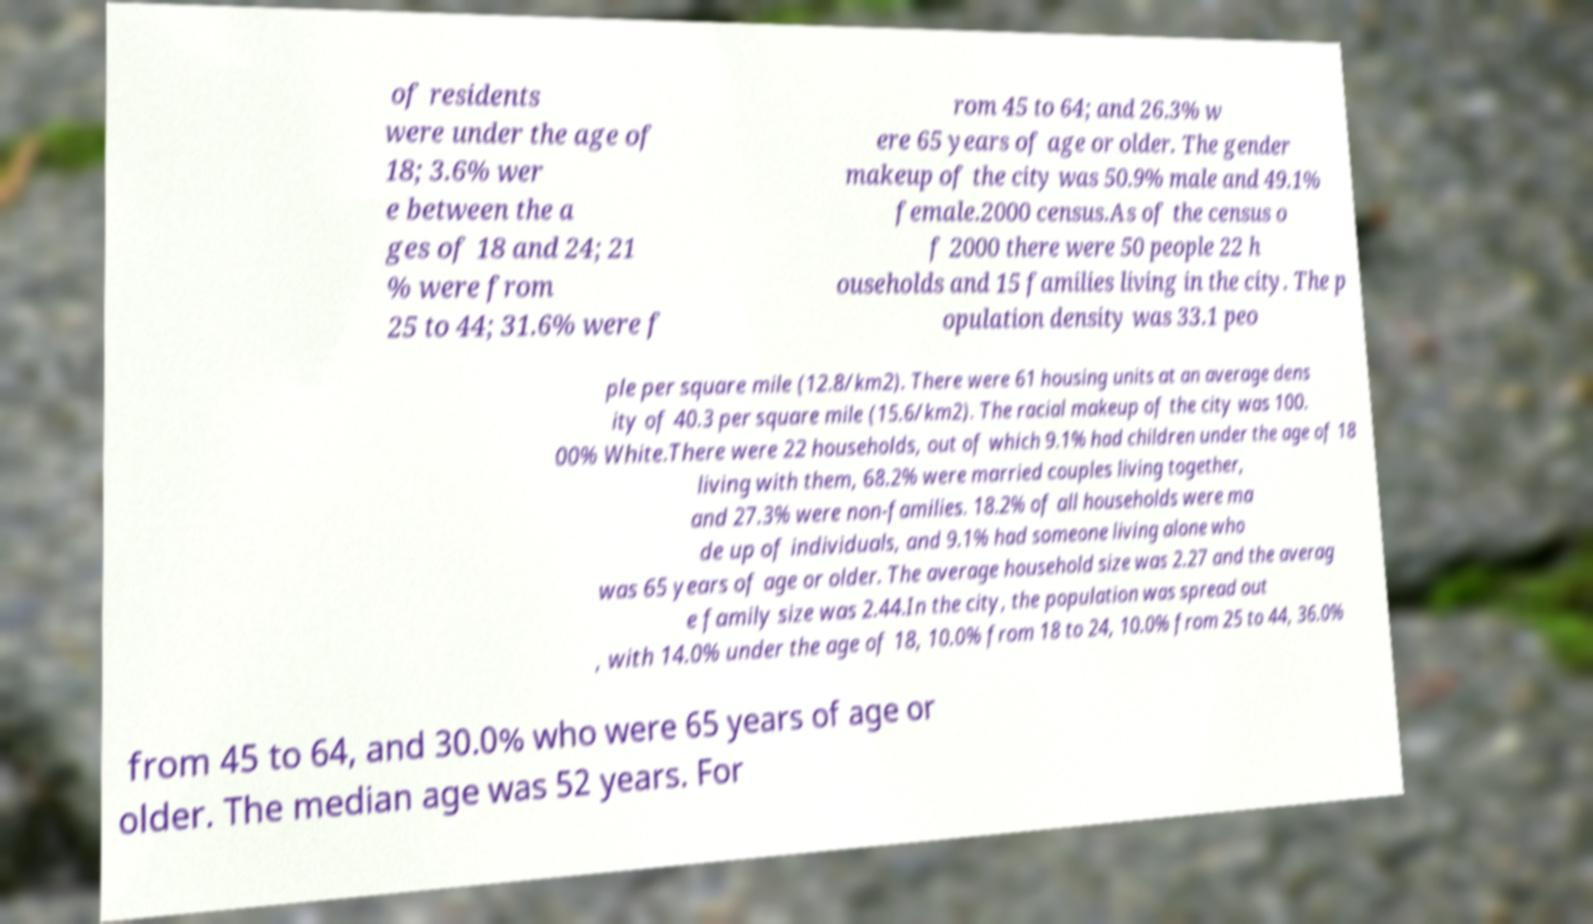Please read and relay the text visible in this image. What does it say? of residents were under the age of 18; 3.6% wer e between the a ges of 18 and 24; 21 % were from 25 to 44; 31.6% were f rom 45 to 64; and 26.3% w ere 65 years of age or older. The gender makeup of the city was 50.9% male and 49.1% female.2000 census.As of the census o f 2000 there were 50 people 22 h ouseholds and 15 families living in the city. The p opulation density was 33.1 peo ple per square mile (12.8/km2). There were 61 housing units at an average dens ity of 40.3 per square mile (15.6/km2). The racial makeup of the city was 100. 00% White.There were 22 households, out of which 9.1% had children under the age of 18 living with them, 68.2% were married couples living together, and 27.3% were non-families. 18.2% of all households were ma de up of individuals, and 9.1% had someone living alone who was 65 years of age or older. The average household size was 2.27 and the averag e family size was 2.44.In the city, the population was spread out , with 14.0% under the age of 18, 10.0% from 18 to 24, 10.0% from 25 to 44, 36.0% from 45 to 64, and 30.0% who were 65 years of age or older. The median age was 52 years. For 